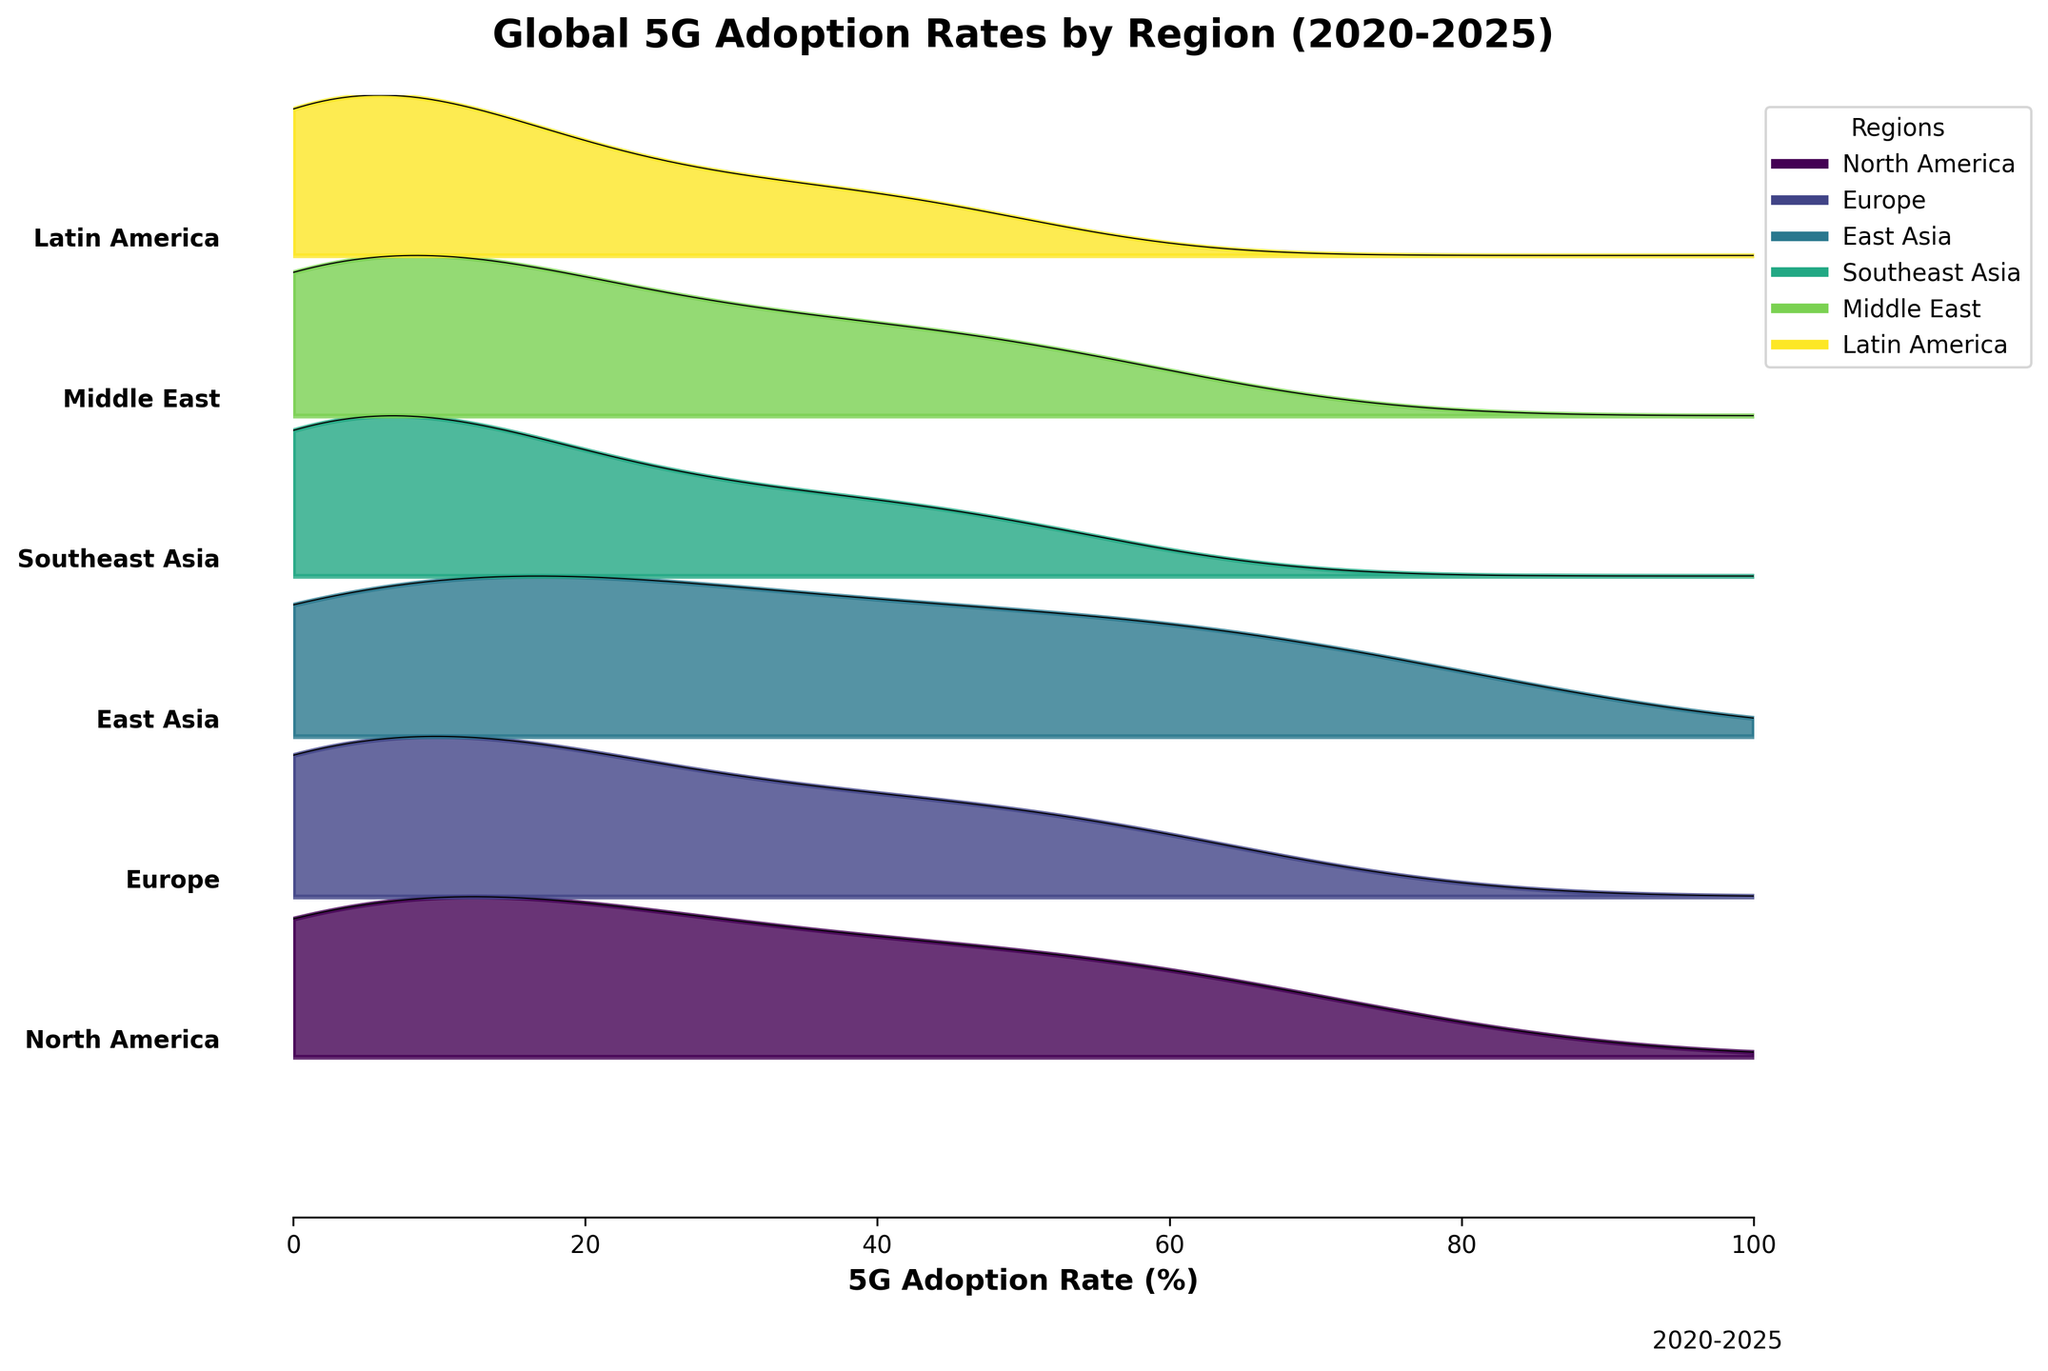What is the title of the figure? The title of a figure is usually displayed at the top and provides a summary of what the plot is about. The title in this figure reads 'Global 5G Adoption Rates by Region (2020-2025)'.
Answer: Global 5G Adoption Rates by Region (2020-2025) How many regions are represented in the figure? We can count the number of unique color-coded regions on the Ridgeline plot. Based on the data provided, the regions are North America, Europe, East Asia, Southeast Asia, Middle East, and Latin America, making a total of 6 regions.
Answer: 6 Which region shows the highest adoption rate of 5G technology in 2025? By examining the Ridgeline plot and looking at the positions of the curves on the x-axis, East Asia has the highest 5G adoption rate in 2025 at 71.2%.
Answer: East Asia How does the 2022 adoption rate in North America compare to Europe? Looking at the 2022 points on the Ridgeline plot, North America's adoption rate is at 12.5% while Europe's is at 9.6%. By comparing these two values, we can see that North America's adoption rate is higher.
Answer: North America is higher Which region had the lowest adoption rate in 2020? By examining the left-most part of the Ridgeline plot for the year 2020, Southeast Asia and Latin America both have a near-zero adoption rate, but Southeast Asia's is slightly lower at 0.1%.
Answer: Southeast Asia In what year does North America surpass 50% adoption rate? By observing the curve for North America, it surpasses the 50% mark between 2024 and 2025. The exact point where it reaches 63.1% is in 2025.
Answer: 2025 Compare the increase in adoption rates from 2020 to 2025 between Europe and the Middle East. From the Ridgeline plot, Europe's adoption rate increases from 0.3% in 2020 to 55.7% in 2025, an increase of 55.4%. The Middle East increases from 0.2% to 51.2%, an increase of 51.0%. Thus, Europe has a slightly higher increase.
Answer: Europe has a higher increase When does East Asia's adoption rate cross 50%? Looking at East Asia's curve in the Ridgeline plot, it crosses the 50% mark between 2023 and 2024, reaching 53.8% in 2024.
Answer: 2024 Which region has the steepest growth curve for 5G adoption? The steepness of the curves on the Ridgeline plot indicates the rate of adoption. East Asia shows the steepest curve, as it starts at a higher initial adoption rate and reaches the highest adoption rate by 2025.
Answer: East Asia 